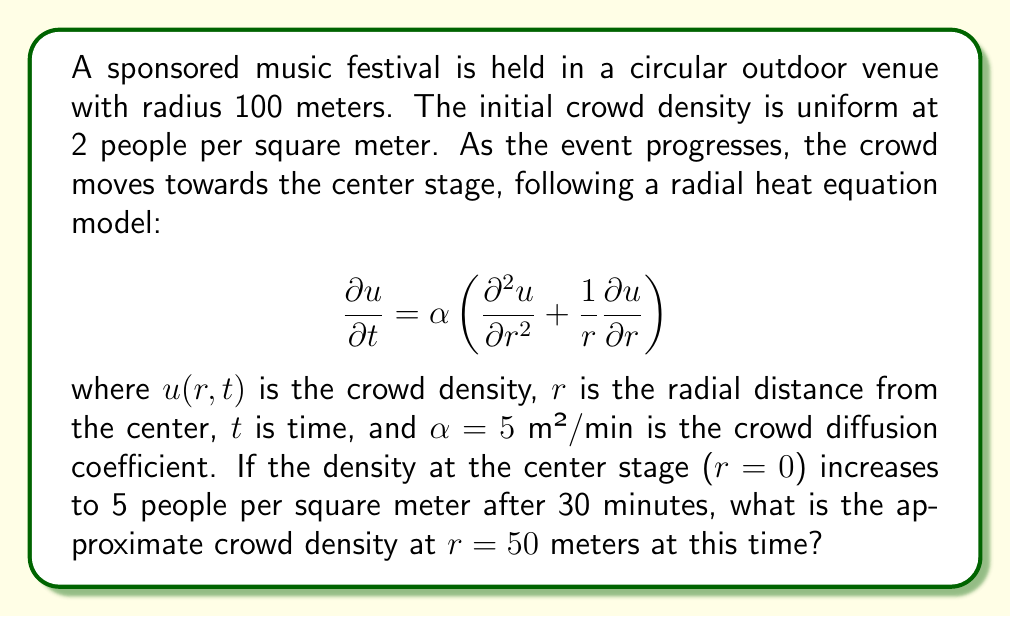Show me your answer to this math problem. To solve this problem, we need to use the fundamental solution of the radial heat equation in two dimensions. The solution for an initial point source at the origin is:

$$u(r,t) = \frac{M}{4\pi\alpha t}e^{-\frac{r^2}{4\alpha t}}$$

where $M$ is the total number of people.

Step 1: Calculate the total number of people (M)
Area of the venue: $A = \pi r^2 = \pi(100)^2 = 10000\pi$ m²
Total people: $M = 2 \text{ people/m²} \times 10000\pi \text{ m²} = 20000\pi$ people

Step 2: Set up the equation for $t = 30$ minutes and $r = 0$
$$5 = \frac{20000\pi}{4\pi(5)(30)}e^{-\frac{0^2}{4(5)(30)}}$$

Step 3: Simplify and solve for the constant factor
$$5 = \frac{20000\pi}{600\pi} = \frac{100}{3}$$

This confirms our setup is correct.

Step 4: Calculate the density at $r = 50$ m and $t = 30$ min
$$u(50,30) = \frac{20000\pi}{4\pi(5)(30)}e^{-\frac{50^2}{4(5)(30)}}$$

$$= \frac{100}{3}e^{-\frac{2500}{600}} \approx 3.32 \text{ people/m²}$$
Answer: 3.32 people/m² 